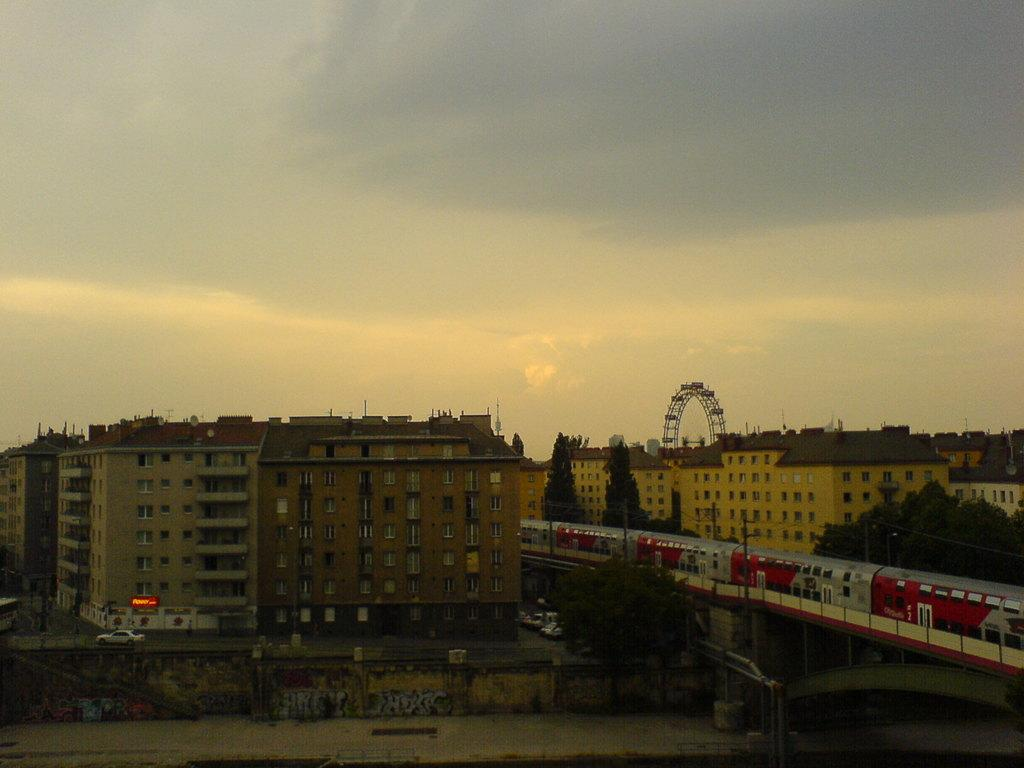What type of structures can be seen in the image? There are buildings in the image. What natural elements are present in the image? There are trees in the image. What amusement park ride is visible in the image? A giant wheel is present in the image. What mode of transportation can be seen in the image? Vehicles and a train are visible in the image. What part of the natural environment is visible in the image? The sky is visible at the top of the image. How would you describe the lighting in the image? The image appears to be slightly dark. What advice does the mother give to the brother in the image? There is no mother or brother present in the image, so no such interaction can be observed. Can you provide an example of a specific vehicle visible in the image? The image does not provide enough detail to identify a specific vehicle, but we can confirm that vehicles are visible in the image. 